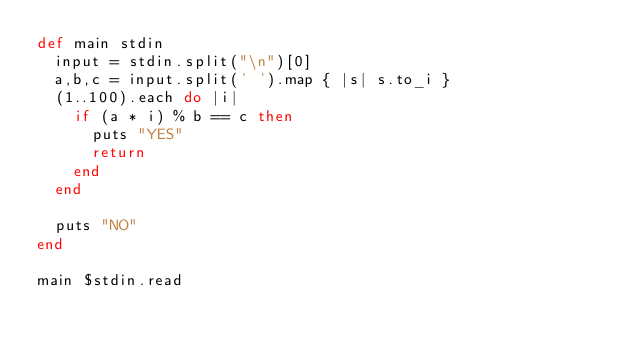Convert code to text. <code><loc_0><loc_0><loc_500><loc_500><_Ruby_>def main stdin
  input = stdin.split("\n")[0]
  a,b,c = input.split(' ').map { |s| s.to_i }
  (1..100).each do |i|
    if (a * i) % b == c then
      puts "YES"
      return
    end
  end

  puts "NO"
end

main $stdin.read
</code> 